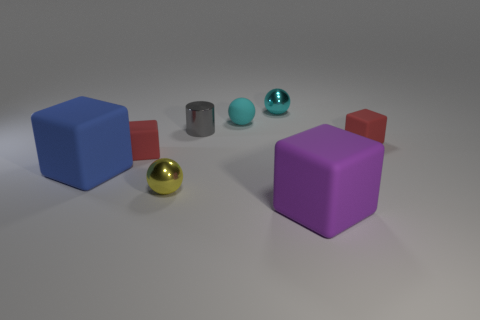Add 2 tiny yellow metallic balls. How many objects exist? 10 Subtract all balls. How many objects are left? 5 Add 2 tiny cyan objects. How many tiny cyan objects are left? 4 Add 4 balls. How many balls exist? 7 Subtract 0 green spheres. How many objects are left? 8 Subtract all small blue matte cylinders. Subtract all yellow things. How many objects are left? 7 